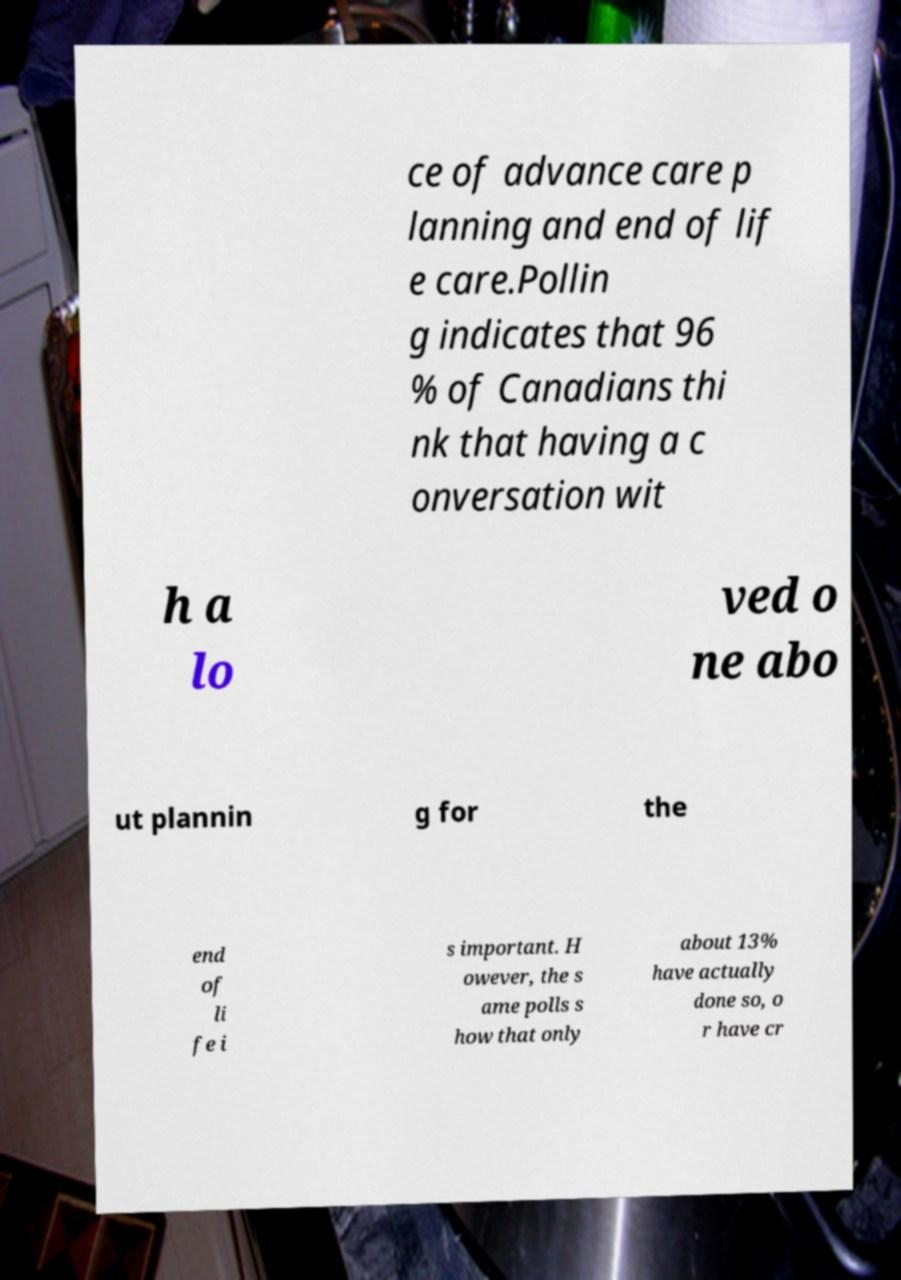For documentation purposes, I need the text within this image transcribed. Could you provide that? ce of advance care p lanning and end of lif e care.Pollin g indicates that 96 % of Canadians thi nk that having a c onversation wit h a lo ved o ne abo ut plannin g for the end of li fe i s important. H owever, the s ame polls s how that only about 13% have actually done so, o r have cr 